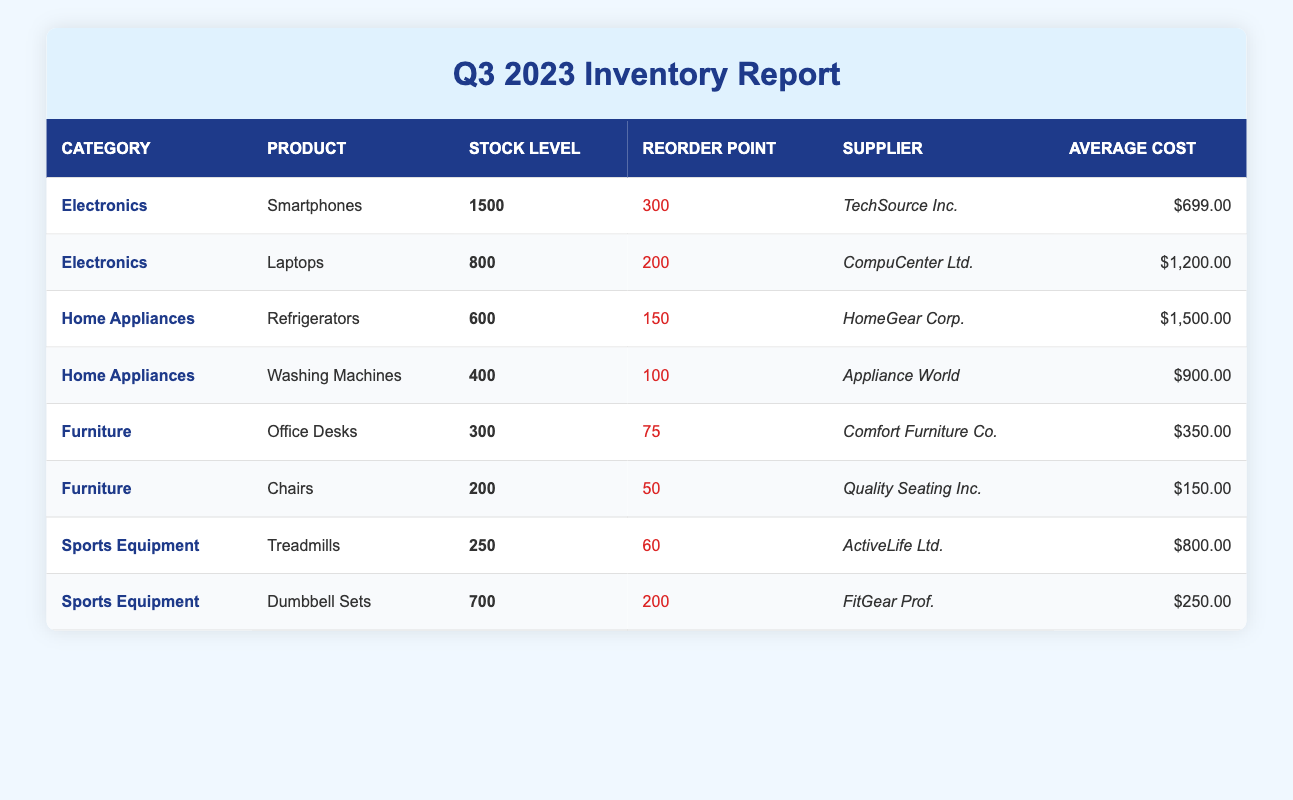What is the stock level of Smartphones? The table lists the stock level for Smartphones in the Electronics category, showing that the value is 1500.
Answer: 1500 Which product requires the lowest amounts of stock before reordering? By examining the Reorder Point column, we find that Chairs have the lowest reorder point at 50.
Answer: 50 What is the average cost of all products in the Furniture category? To calculate the average cost for Furniture: Office Desks ($350) + Chairs ($150) = $500. There are 2 products, so the average cost is $500/2 = $250.
Answer: 250 Is there any product in the Sports Equipment category that has a stock level below the reorder point? The stock level for Treadmills is 250, which is above its reorder point of 60, and Dumbbell Sets at 700 is also above its reorder point of 200. Therefore, there are no products below their reorder points.
Answer: No Which category has the highest stock level among its products? Comparing the total stock levels of all categories: Electronics (1500 + 800 = 2300), Home Appliances (600 + 400 = 1000), Furniture (300 + 200 = 500), and Sports Equipment (250 + 700 = 950), Electronics has the highest combined stock level of 2300.
Answer: Electronics 